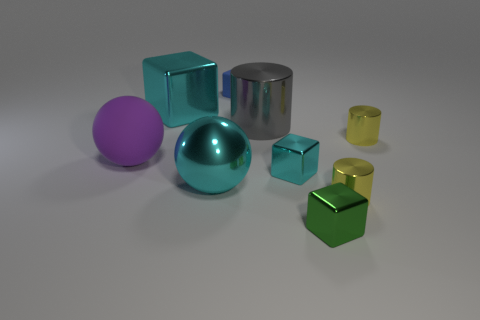Add 1 small green metal blocks. How many objects exist? 10 Subtract all cylinders. How many objects are left? 6 Subtract 1 gray cylinders. How many objects are left? 8 Subtract all green shiny objects. Subtract all small red things. How many objects are left? 8 Add 4 big cubes. How many big cubes are left? 5 Add 3 blue rubber blocks. How many blue rubber blocks exist? 4 